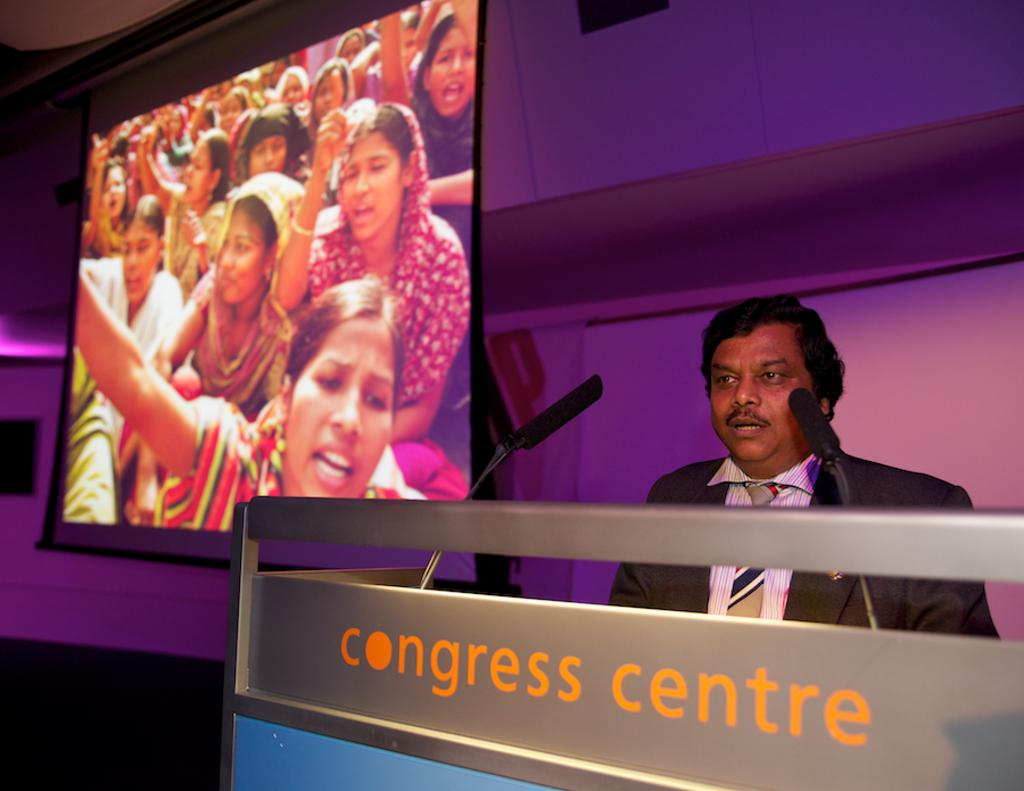What is the person near in the image? The person is standing near the podium. What can be found on the podium? There are microphones on the podium. What is located near the podium? There is a screen near the podium. What is visible in the background of the image? There is a wall in the background of the image. What type of cherries are being used to decorate the wall in the image? There are no cherries present in the image, and the wall is not being decorated with them. 